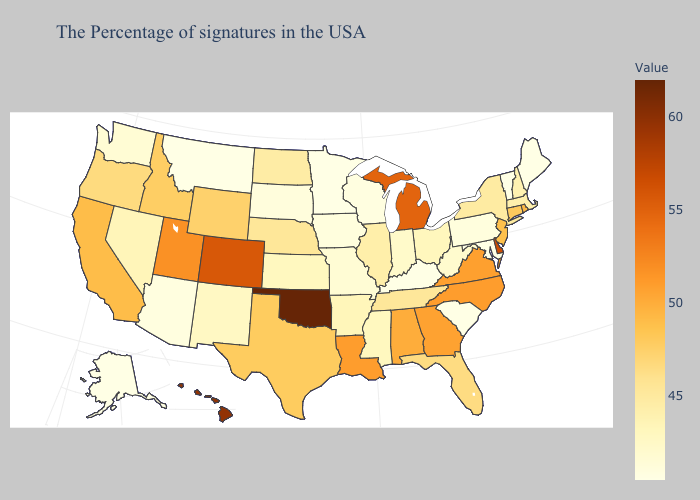Does Oklahoma have the highest value in the USA?
Concise answer only. Yes. Does Maryland have the highest value in the South?
Write a very short answer. No. Does Oklahoma have the highest value in the USA?
Short answer required. Yes. Among the states that border Kentucky , does Virginia have the highest value?
Concise answer only. Yes. Among the states that border Florida , which have the lowest value?
Be succinct. Alabama. Which states have the lowest value in the MidWest?
Answer briefly. Minnesota. 